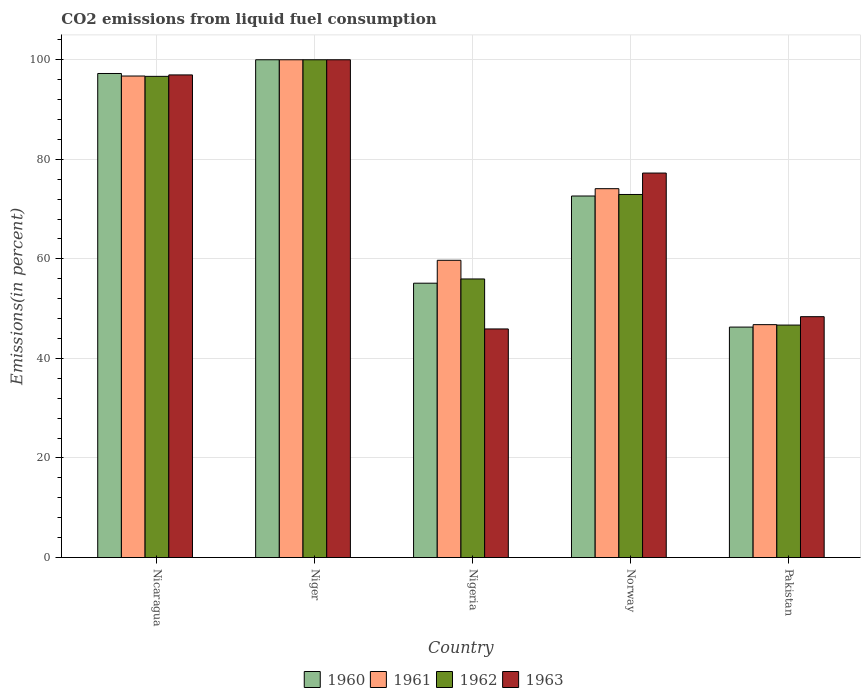How many different coloured bars are there?
Your answer should be very brief. 4. How many groups of bars are there?
Give a very brief answer. 5. Are the number of bars per tick equal to the number of legend labels?
Keep it short and to the point. Yes. Are the number of bars on each tick of the X-axis equal?
Offer a terse response. Yes. What is the total CO2 emitted in 1963 in Nicaragua?
Your response must be concise. 96.96. Across all countries, what is the minimum total CO2 emitted in 1961?
Your response must be concise. 46.79. In which country was the total CO2 emitted in 1962 maximum?
Provide a short and direct response. Niger. In which country was the total CO2 emitted in 1963 minimum?
Keep it short and to the point. Nigeria. What is the total total CO2 emitted in 1961 in the graph?
Provide a succinct answer. 377.33. What is the difference between the total CO2 emitted in 1962 in Niger and that in Norway?
Provide a short and direct response. 27.06. What is the difference between the total CO2 emitted in 1963 in Niger and the total CO2 emitted in 1960 in Norway?
Your answer should be compact. 27.37. What is the average total CO2 emitted in 1962 per country?
Your answer should be very brief. 74.45. What is the difference between the total CO2 emitted of/in 1963 and total CO2 emitted of/in 1962 in Norway?
Provide a short and direct response. 4.3. In how many countries, is the total CO2 emitted in 1960 greater than 8 %?
Your answer should be compact. 5. What is the ratio of the total CO2 emitted in 1960 in Niger to that in Pakistan?
Offer a very short reply. 2.16. Is the difference between the total CO2 emitted in 1963 in Nicaragua and Nigeria greater than the difference between the total CO2 emitted in 1962 in Nicaragua and Nigeria?
Give a very brief answer. Yes. What is the difference between the highest and the second highest total CO2 emitted in 1961?
Keep it short and to the point. 22.63. What is the difference between the highest and the lowest total CO2 emitted in 1962?
Offer a terse response. 53.3. In how many countries, is the total CO2 emitted in 1960 greater than the average total CO2 emitted in 1960 taken over all countries?
Give a very brief answer. 2. Is the sum of the total CO2 emitted in 1961 in Nigeria and Norway greater than the maximum total CO2 emitted in 1960 across all countries?
Make the answer very short. Yes. Is it the case that in every country, the sum of the total CO2 emitted in 1961 and total CO2 emitted in 1960 is greater than the sum of total CO2 emitted in 1963 and total CO2 emitted in 1962?
Offer a terse response. No. What does the 4th bar from the left in Nigeria represents?
Make the answer very short. 1963. What does the 1st bar from the right in Nigeria represents?
Your answer should be very brief. 1963. How many bars are there?
Give a very brief answer. 20. Are all the bars in the graph horizontal?
Your answer should be very brief. No. How many countries are there in the graph?
Provide a short and direct response. 5. What is the difference between two consecutive major ticks on the Y-axis?
Give a very brief answer. 20. Does the graph contain any zero values?
Your answer should be very brief. No. Where does the legend appear in the graph?
Give a very brief answer. Bottom center. How many legend labels are there?
Your response must be concise. 4. How are the legend labels stacked?
Your answer should be compact. Horizontal. What is the title of the graph?
Provide a short and direct response. CO2 emissions from liquid fuel consumption. Does "1993" appear as one of the legend labels in the graph?
Provide a short and direct response. No. What is the label or title of the Y-axis?
Provide a short and direct response. Emissions(in percent). What is the Emissions(in percent) of 1960 in Nicaragua?
Your answer should be very brief. 97.24. What is the Emissions(in percent) of 1961 in Nicaragua?
Provide a short and direct response. 96.73. What is the Emissions(in percent) of 1962 in Nicaragua?
Your response must be concise. 96.67. What is the Emissions(in percent) in 1963 in Nicaragua?
Your response must be concise. 96.96. What is the Emissions(in percent) of 1960 in Niger?
Keep it short and to the point. 100. What is the Emissions(in percent) in 1961 in Niger?
Your answer should be compact. 100. What is the Emissions(in percent) of 1960 in Nigeria?
Make the answer very short. 55.11. What is the Emissions(in percent) in 1961 in Nigeria?
Ensure brevity in your answer.  59.71. What is the Emissions(in percent) in 1962 in Nigeria?
Your answer should be compact. 55.96. What is the Emissions(in percent) of 1963 in Nigeria?
Your answer should be compact. 45.92. What is the Emissions(in percent) of 1960 in Norway?
Ensure brevity in your answer.  72.63. What is the Emissions(in percent) of 1961 in Norway?
Your answer should be compact. 74.1. What is the Emissions(in percent) of 1962 in Norway?
Make the answer very short. 72.94. What is the Emissions(in percent) of 1963 in Norway?
Keep it short and to the point. 77.24. What is the Emissions(in percent) in 1960 in Pakistan?
Provide a short and direct response. 46.3. What is the Emissions(in percent) of 1961 in Pakistan?
Your answer should be very brief. 46.79. What is the Emissions(in percent) of 1962 in Pakistan?
Give a very brief answer. 46.7. What is the Emissions(in percent) in 1963 in Pakistan?
Ensure brevity in your answer.  48.39. Across all countries, what is the maximum Emissions(in percent) of 1962?
Provide a short and direct response. 100. Across all countries, what is the maximum Emissions(in percent) of 1963?
Your response must be concise. 100. Across all countries, what is the minimum Emissions(in percent) in 1960?
Keep it short and to the point. 46.3. Across all countries, what is the minimum Emissions(in percent) of 1961?
Your response must be concise. 46.79. Across all countries, what is the minimum Emissions(in percent) in 1962?
Give a very brief answer. 46.7. Across all countries, what is the minimum Emissions(in percent) in 1963?
Your answer should be compact. 45.92. What is the total Emissions(in percent) in 1960 in the graph?
Your answer should be very brief. 371.28. What is the total Emissions(in percent) in 1961 in the graph?
Keep it short and to the point. 377.33. What is the total Emissions(in percent) in 1962 in the graph?
Your answer should be compact. 372.27. What is the total Emissions(in percent) in 1963 in the graph?
Give a very brief answer. 368.5. What is the difference between the Emissions(in percent) in 1960 in Nicaragua and that in Niger?
Provide a succinct answer. -2.76. What is the difference between the Emissions(in percent) in 1961 in Nicaragua and that in Niger?
Provide a short and direct response. -3.27. What is the difference between the Emissions(in percent) of 1963 in Nicaragua and that in Niger?
Provide a succinct answer. -3.04. What is the difference between the Emissions(in percent) in 1960 in Nicaragua and that in Nigeria?
Your answer should be very brief. 42.13. What is the difference between the Emissions(in percent) in 1961 in Nicaragua and that in Nigeria?
Keep it short and to the point. 37.02. What is the difference between the Emissions(in percent) of 1962 in Nicaragua and that in Nigeria?
Provide a short and direct response. 40.7. What is the difference between the Emissions(in percent) in 1963 in Nicaragua and that in Nigeria?
Give a very brief answer. 51.03. What is the difference between the Emissions(in percent) of 1960 in Nicaragua and that in Norway?
Give a very brief answer. 24.61. What is the difference between the Emissions(in percent) of 1961 in Nicaragua and that in Norway?
Offer a very short reply. 22.63. What is the difference between the Emissions(in percent) of 1962 in Nicaragua and that in Norway?
Your answer should be compact. 23.73. What is the difference between the Emissions(in percent) of 1963 in Nicaragua and that in Norway?
Give a very brief answer. 19.72. What is the difference between the Emissions(in percent) in 1960 in Nicaragua and that in Pakistan?
Provide a succinct answer. 50.95. What is the difference between the Emissions(in percent) in 1961 in Nicaragua and that in Pakistan?
Offer a very short reply. 49.95. What is the difference between the Emissions(in percent) of 1962 in Nicaragua and that in Pakistan?
Provide a succinct answer. 49.97. What is the difference between the Emissions(in percent) in 1963 in Nicaragua and that in Pakistan?
Your answer should be compact. 48.57. What is the difference between the Emissions(in percent) of 1960 in Niger and that in Nigeria?
Keep it short and to the point. 44.89. What is the difference between the Emissions(in percent) in 1961 in Niger and that in Nigeria?
Ensure brevity in your answer.  40.29. What is the difference between the Emissions(in percent) in 1962 in Niger and that in Nigeria?
Offer a very short reply. 44.04. What is the difference between the Emissions(in percent) in 1963 in Niger and that in Nigeria?
Your answer should be compact. 54.08. What is the difference between the Emissions(in percent) in 1960 in Niger and that in Norway?
Provide a short and direct response. 27.37. What is the difference between the Emissions(in percent) of 1961 in Niger and that in Norway?
Offer a very short reply. 25.9. What is the difference between the Emissions(in percent) of 1962 in Niger and that in Norway?
Keep it short and to the point. 27.06. What is the difference between the Emissions(in percent) of 1963 in Niger and that in Norway?
Provide a succinct answer. 22.76. What is the difference between the Emissions(in percent) of 1960 in Niger and that in Pakistan?
Offer a terse response. 53.7. What is the difference between the Emissions(in percent) of 1961 in Niger and that in Pakistan?
Offer a very short reply. 53.21. What is the difference between the Emissions(in percent) in 1962 in Niger and that in Pakistan?
Your answer should be very brief. 53.3. What is the difference between the Emissions(in percent) of 1963 in Niger and that in Pakistan?
Provide a short and direct response. 51.61. What is the difference between the Emissions(in percent) in 1960 in Nigeria and that in Norway?
Offer a very short reply. -17.52. What is the difference between the Emissions(in percent) in 1961 in Nigeria and that in Norway?
Offer a terse response. -14.39. What is the difference between the Emissions(in percent) of 1962 in Nigeria and that in Norway?
Offer a terse response. -16.97. What is the difference between the Emissions(in percent) in 1963 in Nigeria and that in Norway?
Provide a succinct answer. -31.32. What is the difference between the Emissions(in percent) of 1960 in Nigeria and that in Pakistan?
Provide a short and direct response. 8.82. What is the difference between the Emissions(in percent) in 1961 in Nigeria and that in Pakistan?
Your answer should be very brief. 12.93. What is the difference between the Emissions(in percent) of 1962 in Nigeria and that in Pakistan?
Offer a terse response. 9.27. What is the difference between the Emissions(in percent) of 1963 in Nigeria and that in Pakistan?
Offer a very short reply. -2.46. What is the difference between the Emissions(in percent) of 1960 in Norway and that in Pakistan?
Your answer should be very brief. 26.33. What is the difference between the Emissions(in percent) in 1961 in Norway and that in Pakistan?
Give a very brief answer. 27.32. What is the difference between the Emissions(in percent) in 1962 in Norway and that in Pakistan?
Provide a short and direct response. 26.24. What is the difference between the Emissions(in percent) of 1963 in Norway and that in Pakistan?
Your answer should be very brief. 28.85. What is the difference between the Emissions(in percent) in 1960 in Nicaragua and the Emissions(in percent) in 1961 in Niger?
Make the answer very short. -2.76. What is the difference between the Emissions(in percent) in 1960 in Nicaragua and the Emissions(in percent) in 1962 in Niger?
Offer a terse response. -2.76. What is the difference between the Emissions(in percent) of 1960 in Nicaragua and the Emissions(in percent) of 1963 in Niger?
Provide a short and direct response. -2.76. What is the difference between the Emissions(in percent) of 1961 in Nicaragua and the Emissions(in percent) of 1962 in Niger?
Ensure brevity in your answer.  -3.27. What is the difference between the Emissions(in percent) of 1961 in Nicaragua and the Emissions(in percent) of 1963 in Niger?
Offer a very short reply. -3.27. What is the difference between the Emissions(in percent) in 1962 in Nicaragua and the Emissions(in percent) in 1963 in Niger?
Your answer should be compact. -3.33. What is the difference between the Emissions(in percent) of 1960 in Nicaragua and the Emissions(in percent) of 1961 in Nigeria?
Offer a terse response. 37.53. What is the difference between the Emissions(in percent) in 1960 in Nicaragua and the Emissions(in percent) in 1962 in Nigeria?
Give a very brief answer. 41.28. What is the difference between the Emissions(in percent) of 1960 in Nicaragua and the Emissions(in percent) of 1963 in Nigeria?
Offer a terse response. 51.32. What is the difference between the Emissions(in percent) of 1961 in Nicaragua and the Emissions(in percent) of 1962 in Nigeria?
Give a very brief answer. 40.77. What is the difference between the Emissions(in percent) in 1961 in Nicaragua and the Emissions(in percent) in 1963 in Nigeria?
Make the answer very short. 50.81. What is the difference between the Emissions(in percent) in 1962 in Nicaragua and the Emissions(in percent) in 1963 in Nigeria?
Keep it short and to the point. 50.74. What is the difference between the Emissions(in percent) of 1960 in Nicaragua and the Emissions(in percent) of 1961 in Norway?
Keep it short and to the point. 23.14. What is the difference between the Emissions(in percent) in 1960 in Nicaragua and the Emissions(in percent) in 1962 in Norway?
Provide a succinct answer. 24.31. What is the difference between the Emissions(in percent) of 1960 in Nicaragua and the Emissions(in percent) of 1963 in Norway?
Your response must be concise. 20. What is the difference between the Emissions(in percent) of 1961 in Nicaragua and the Emissions(in percent) of 1962 in Norway?
Provide a succinct answer. 23.8. What is the difference between the Emissions(in percent) in 1961 in Nicaragua and the Emissions(in percent) in 1963 in Norway?
Make the answer very short. 19.49. What is the difference between the Emissions(in percent) in 1962 in Nicaragua and the Emissions(in percent) in 1963 in Norway?
Offer a terse response. 19.43. What is the difference between the Emissions(in percent) in 1960 in Nicaragua and the Emissions(in percent) in 1961 in Pakistan?
Keep it short and to the point. 50.46. What is the difference between the Emissions(in percent) of 1960 in Nicaragua and the Emissions(in percent) of 1962 in Pakistan?
Offer a very short reply. 50.54. What is the difference between the Emissions(in percent) of 1960 in Nicaragua and the Emissions(in percent) of 1963 in Pakistan?
Your answer should be very brief. 48.86. What is the difference between the Emissions(in percent) of 1961 in Nicaragua and the Emissions(in percent) of 1962 in Pakistan?
Offer a terse response. 50.03. What is the difference between the Emissions(in percent) in 1961 in Nicaragua and the Emissions(in percent) in 1963 in Pakistan?
Your answer should be very brief. 48.35. What is the difference between the Emissions(in percent) of 1962 in Nicaragua and the Emissions(in percent) of 1963 in Pakistan?
Provide a succinct answer. 48.28. What is the difference between the Emissions(in percent) of 1960 in Niger and the Emissions(in percent) of 1961 in Nigeria?
Ensure brevity in your answer.  40.29. What is the difference between the Emissions(in percent) of 1960 in Niger and the Emissions(in percent) of 1962 in Nigeria?
Give a very brief answer. 44.04. What is the difference between the Emissions(in percent) in 1960 in Niger and the Emissions(in percent) in 1963 in Nigeria?
Offer a very short reply. 54.08. What is the difference between the Emissions(in percent) of 1961 in Niger and the Emissions(in percent) of 1962 in Nigeria?
Provide a succinct answer. 44.04. What is the difference between the Emissions(in percent) in 1961 in Niger and the Emissions(in percent) in 1963 in Nigeria?
Your answer should be compact. 54.08. What is the difference between the Emissions(in percent) in 1962 in Niger and the Emissions(in percent) in 1963 in Nigeria?
Make the answer very short. 54.08. What is the difference between the Emissions(in percent) of 1960 in Niger and the Emissions(in percent) of 1961 in Norway?
Ensure brevity in your answer.  25.9. What is the difference between the Emissions(in percent) of 1960 in Niger and the Emissions(in percent) of 1962 in Norway?
Ensure brevity in your answer.  27.06. What is the difference between the Emissions(in percent) in 1960 in Niger and the Emissions(in percent) in 1963 in Norway?
Provide a short and direct response. 22.76. What is the difference between the Emissions(in percent) of 1961 in Niger and the Emissions(in percent) of 1962 in Norway?
Keep it short and to the point. 27.06. What is the difference between the Emissions(in percent) of 1961 in Niger and the Emissions(in percent) of 1963 in Norway?
Offer a terse response. 22.76. What is the difference between the Emissions(in percent) of 1962 in Niger and the Emissions(in percent) of 1963 in Norway?
Ensure brevity in your answer.  22.76. What is the difference between the Emissions(in percent) of 1960 in Niger and the Emissions(in percent) of 1961 in Pakistan?
Make the answer very short. 53.21. What is the difference between the Emissions(in percent) of 1960 in Niger and the Emissions(in percent) of 1962 in Pakistan?
Provide a short and direct response. 53.3. What is the difference between the Emissions(in percent) of 1960 in Niger and the Emissions(in percent) of 1963 in Pakistan?
Make the answer very short. 51.61. What is the difference between the Emissions(in percent) of 1961 in Niger and the Emissions(in percent) of 1962 in Pakistan?
Your answer should be very brief. 53.3. What is the difference between the Emissions(in percent) of 1961 in Niger and the Emissions(in percent) of 1963 in Pakistan?
Your response must be concise. 51.61. What is the difference between the Emissions(in percent) in 1962 in Niger and the Emissions(in percent) in 1963 in Pakistan?
Your response must be concise. 51.61. What is the difference between the Emissions(in percent) in 1960 in Nigeria and the Emissions(in percent) in 1961 in Norway?
Provide a short and direct response. -18.99. What is the difference between the Emissions(in percent) of 1960 in Nigeria and the Emissions(in percent) of 1962 in Norway?
Keep it short and to the point. -17.82. What is the difference between the Emissions(in percent) in 1960 in Nigeria and the Emissions(in percent) in 1963 in Norway?
Provide a short and direct response. -22.13. What is the difference between the Emissions(in percent) of 1961 in Nigeria and the Emissions(in percent) of 1962 in Norway?
Your response must be concise. -13.22. What is the difference between the Emissions(in percent) in 1961 in Nigeria and the Emissions(in percent) in 1963 in Norway?
Your answer should be compact. -17.52. What is the difference between the Emissions(in percent) in 1962 in Nigeria and the Emissions(in percent) in 1963 in Norway?
Keep it short and to the point. -21.27. What is the difference between the Emissions(in percent) in 1960 in Nigeria and the Emissions(in percent) in 1961 in Pakistan?
Give a very brief answer. 8.33. What is the difference between the Emissions(in percent) in 1960 in Nigeria and the Emissions(in percent) in 1962 in Pakistan?
Make the answer very short. 8.41. What is the difference between the Emissions(in percent) of 1960 in Nigeria and the Emissions(in percent) of 1963 in Pakistan?
Your answer should be compact. 6.73. What is the difference between the Emissions(in percent) in 1961 in Nigeria and the Emissions(in percent) in 1962 in Pakistan?
Ensure brevity in your answer.  13.02. What is the difference between the Emissions(in percent) in 1961 in Nigeria and the Emissions(in percent) in 1963 in Pakistan?
Your response must be concise. 11.33. What is the difference between the Emissions(in percent) in 1962 in Nigeria and the Emissions(in percent) in 1963 in Pakistan?
Provide a succinct answer. 7.58. What is the difference between the Emissions(in percent) in 1960 in Norway and the Emissions(in percent) in 1961 in Pakistan?
Offer a terse response. 25.84. What is the difference between the Emissions(in percent) of 1960 in Norway and the Emissions(in percent) of 1962 in Pakistan?
Your response must be concise. 25.93. What is the difference between the Emissions(in percent) of 1960 in Norway and the Emissions(in percent) of 1963 in Pakistan?
Offer a very short reply. 24.24. What is the difference between the Emissions(in percent) in 1961 in Norway and the Emissions(in percent) in 1962 in Pakistan?
Provide a succinct answer. 27.4. What is the difference between the Emissions(in percent) in 1961 in Norway and the Emissions(in percent) in 1963 in Pakistan?
Provide a succinct answer. 25.71. What is the difference between the Emissions(in percent) of 1962 in Norway and the Emissions(in percent) of 1963 in Pakistan?
Offer a terse response. 24.55. What is the average Emissions(in percent) in 1960 per country?
Your answer should be compact. 74.26. What is the average Emissions(in percent) of 1961 per country?
Your response must be concise. 75.47. What is the average Emissions(in percent) in 1962 per country?
Your response must be concise. 74.45. What is the average Emissions(in percent) of 1963 per country?
Make the answer very short. 73.7. What is the difference between the Emissions(in percent) of 1960 and Emissions(in percent) of 1961 in Nicaragua?
Keep it short and to the point. 0.51. What is the difference between the Emissions(in percent) of 1960 and Emissions(in percent) of 1962 in Nicaragua?
Offer a very short reply. 0.57. What is the difference between the Emissions(in percent) of 1960 and Emissions(in percent) of 1963 in Nicaragua?
Provide a short and direct response. 0.28. What is the difference between the Emissions(in percent) of 1961 and Emissions(in percent) of 1962 in Nicaragua?
Give a very brief answer. 0.07. What is the difference between the Emissions(in percent) of 1961 and Emissions(in percent) of 1963 in Nicaragua?
Keep it short and to the point. -0.22. What is the difference between the Emissions(in percent) in 1962 and Emissions(in percent) in 1963 in Nicaragua?
Your response must be concise. -0.29. What is the difference between the Emissions(in percent) in 1960 and Emissions(in percent) in 1961 in Niger?
Give a very brief answer. 0. What is the difference between the Emissions(in percent) in 1961 and Emissions(in percent) in 1963 in Niger?
Give a very brief answer. 0. What is the difference between the Emissions(in percent) in 1960 and Emissions(in percent) in 1961 in Nigeria?
Provide a short and direct response. -4.6. What is the difference between the Emissions(in percent) in 1960 and Emissions(in percent) in 1962 in Nigeria?
Your response must be concise. -0.85. What is the difference between the Emissions(in percent) of 1960 and Emissions(in percent) of 1963 in Nigeria?
Your response must be concise. 9.19. What is the difference between the Emissions(in percent) in 1961 and Emissions(in percent) in 1962 in Nigeria?
Your answer should be very brief. 3.75. What is the difference between the Emissions(in percent) of 1961 and Emissions(in percent) of 1963 in Nigeria?
Offer a terse response. 13.79. What is the difference between the Emissions(in percent) of 1962 and Emissions(in percent) of 1963 in Nigeria?
Keep it short and to the point. 10.04. What is the difference between the Emissions(in percent) of 1960 and Emissions(in percent) of 1961 in Norway?
Ensure brevity in your answer.  -1.47. What is the difference between the Emissions(in percent) of 1960 and Emissions(in percent) of 1962 in Norway?
Your response must be concise. -0.31. What is the difference between the Emissions(in percent) in 1960 and Emissions(in percent) in 1963 in Norway?
Keep it short and to the point. -4.61. What is the difference between the Emissions(in percent) of 1961 and Emissions(in percent) of 1962 in Norway?
Offer a terse response. 1.16. What is the difference between the Emissions(in percent) of 1961 and Emissions(in percent) of 1963 in Norway?
Ensure brevity in your answer.  -3.14. What is the difference between the Emissions(in percent) in 1962 and Emissions(in percent) in 1963 in Norway?
Your answer should be compact. -4.3. What is the difference between the Emissions(in percent) in 1960 and Emissions(in percent) in 1961 in Pakistan?
Offer a very short reply. -0.49. What is the difference between the Emissions(in percent) in 1960 and Emissions(in percent) in 1962 in Pakistan?
Offer a very short reply. -0.4. What is the difference between the Emissions(in percent) of 1960 and Emissions(in percent) of 1963 in Pakistan?
Provide a succinct answer. -2.09. What is the difference between the Emissions(in percent) in 1961 and Emissions(in percent) in 1962 in Pakistan?
Keep it short and to the point. 0.09. What is the difference between the Emissions(in percent) of 1961 and Emissions(in percent) of 1963 in Pakistan?
Provide a succinct answer. -1.6. What is the difference between the Emissions(in percent) in 1962 and Emissions(in percent) in 1963 in Pakistan?
Offer a terse response. -1.69. What is the ratio of the Emissions(in percent) of 1960 in Nicaragua to that in Niger?
Make the answer very short. 0.97. What is the ratio of the Emissions(in percent) of 1961 in Nicaragua to that in Niger?
Your answer should be compact. 0.97. What is the ratio of the Emissions(in percent) in 1962 in Nicaragua to that in Niger?
Offer a very short reply. 0.97. What is the ratio of the Emissions(in percent) in 1963 in Nicaragua to that in Niger?
Provide a succinct answer. 0.97. What is the ratio of the Emissions(in percent) of 1960 in Nicaragua to that in Nigeria?
Your answer should be compact. 1.76. What is the ratio of the Emissions(in percent) of 1961 in Nicaragua to that in Nigeria?
Provide a succinct answer. 1.62. What is the ratio of the Emissions(in percent) in 1962 in Nicaragua to that in Nigeria?
Your response must be concise. 1.73. What is the ratio of the Emissions(in percent) of 1963 in Nicaragua to that in Nigeria?
Offer a very short reply. 2.11. What is the ratio of the Emissions(in percent) in 1960 in Nicaragua to that in Norway?
Make the answer very short. 1.34. What is the ratio of the Emissions(in percent) in 1961 in Nicaragua to that in Norway?
Your answer should be compact. 1.31. What is the ratio of the Emissions(in percent) in 1962 in Nicaragua to that in Norway?
Make the answer very short. 1.33. What is the ratio of the Emissions(in percent) in 1963 in Nicaragua to that in Norway?
Your answer should be very brief. 1.26. What is the ratio of the Emissions(in percent) in 1960 in Nicaragua to that in Pakistan?
Give a very brief answer. 2.1. What is the ratio of the Emissions(in percent) in 1961 in Nicaragua to that in Pakistan?
Offer a terse response. 2.07. What is the ratio of the Emissions(in percent) in 1962 in Nicaragua to that in Pakistan?
Make the answer very short. 2.07. What is the ratio of the Emissions(in percent) of 1963 in Nicaragua to that in Pakistan?
Your response must be concise. 2. What is the ratio of the Emissions(in percent) in 1960 in Niger to that in Nigeria?
Keep it short and to the point. 1.81. What is the ratio of the Emissions(in percent) in 1961 in Niger to that in Nigeria?
Give a very brief answer. 1.67. What is the ratio of the Emissions(in percent) in 1962 in Niger to that in Nigeria?
Provide a short and direct response. 1.79. What is the ratio of the Emissions(in percent) of 1963 in Niger to that in Nigeria?
Your answer should be very brief. 2.18. What is the ratio of the Emissions(in percent) of 1960 in Niger to that in Norway?
Make the answer very short. 1.38. What is the ratio of the Emissions(in percent) of 1961 in Niger to that in Norway?
Make the answer very short. 1.35. What is the ratio of the Emissions(in percent) in 1962 in Niger to that in Norway?
Provide a short and direct response. 1.37. What is the ratio of the Emissions(in percent) of 1963 in Niger to that in Norway?
Ensure brevity in your answer.  1.29. What is the ratio of the Emissions(in percent) of 1960 in Niger to that in Pakistan?
Your answer should be very brief. 2.16. What is the ratio of the Emissions(in percent) of 1961 in Niger to that in Pakistan?
Offer a very short reply. 2.14. What is the ratio of the Emissions(in percent) of 1962 in Niger to that in Pakistan?
Offer a very short reply. 2.14. What is the ratio of the Emissions(in percent) in 1963 in Niger to that in Pakistan?
Provide a short and direct response. 2.07. What is the ratio of the Emissions(in percent) of 1960 in Nigeria to that in Norway?
Give a very brief answer. 0.76. What is the ratio of the Emissions(in percent) of 1961 in Nigeria to that in Norway?
Keep it short and to the point. 0.81. What is the ratio of the Emissions(in percent) in 1962 in Nigeria to that in Norway?
Offer a terse response. 0.77. What is the ratio of the Emissions(in percent) in 1963 in Nigeria to that in Norway?
Your response must be concise. 0.59. What is the ratio of the Emissions(in percent) in 1960 in Nigeria to that in Pakistan?
Your answer should be very brief. 1.19. What is the ratio of the Emissions(in percent) in 1961 in Nigeria to that in Pakistan?
Ensure brevity in your answer.  1.28. What is the ratio of the Emissions(in percent) of 1962 in Nigeria to that in Pakistan?
Your response must be concise. 1.2. What is the ratio of the Emissions(in percent) in 1963 in Nigeria to that in Pakistan?
Provide a succinct answer. 0.95. What is the ratio of the Emissions(in percent) in 1960 in Norway to that in Pakistan?
Provide a succinct answer. 1.57. What is the ratio of the Emissions(in percent) in 1961 in Norway to that in Pakistan?
Offer a very short reply. 1.58. What is the ratio of the Emissions(in percent) of 1962 in Norway to that in Pakistan?
Keep it short and to the point. 1.56. What is the ratio of the Emissions(in percent) of 1963 in Norway to that in Pakistan?
Keep it short and to the point. 1.6. What is the difference between the highest and the second highest Emissions(in percent) in 1960?
Provide a succinct answer. 2.76. What is the difference between the highest and the second highest Emissions(in percent) in 1961?
Make the answer very short. 3.27. What is the difference between the highest and the second highest Emissions(in percent) in 1963?
Give a very brief answer. 3.04. What is the difference between the highest and the lowest Emissions(in percent) of 1960?
Provide a short and direct response. 53.7. What is the difference between the highest and the lowest Emissions(in percent) in 1961?
Your answer should be compact. 53.21. What is the difference between the highest and the lowest Emissions(in percent) of 1962?
Your response must be concise. 53.3. What is the difference between the highest and the lowest Emissions(in percent) of 1963?
Ensure brevity in your answer.  54.08. 